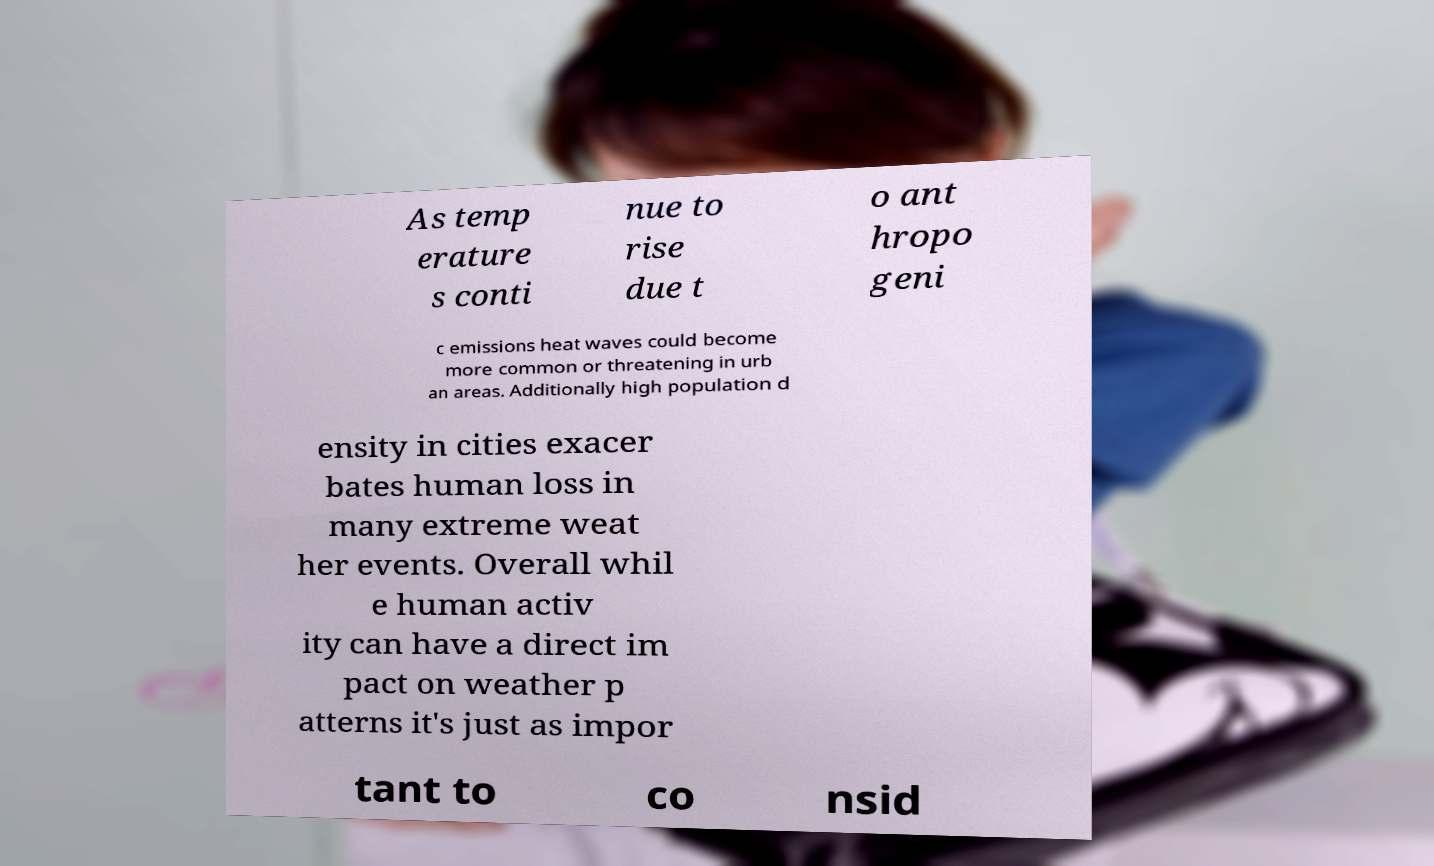Can you accurately transcribe the text from the provided image for me? As temp erature s conti nue to rise due t o ant hropo geni c emissions heat waves could become more common or threatening in urb an areas. Additionally high population d ensity in cities exacer bates human loss in many extreme weat her events. Overall whil e human activ ity can have a direct im pact on weather p atterns it's just as impor tant to co nsid 